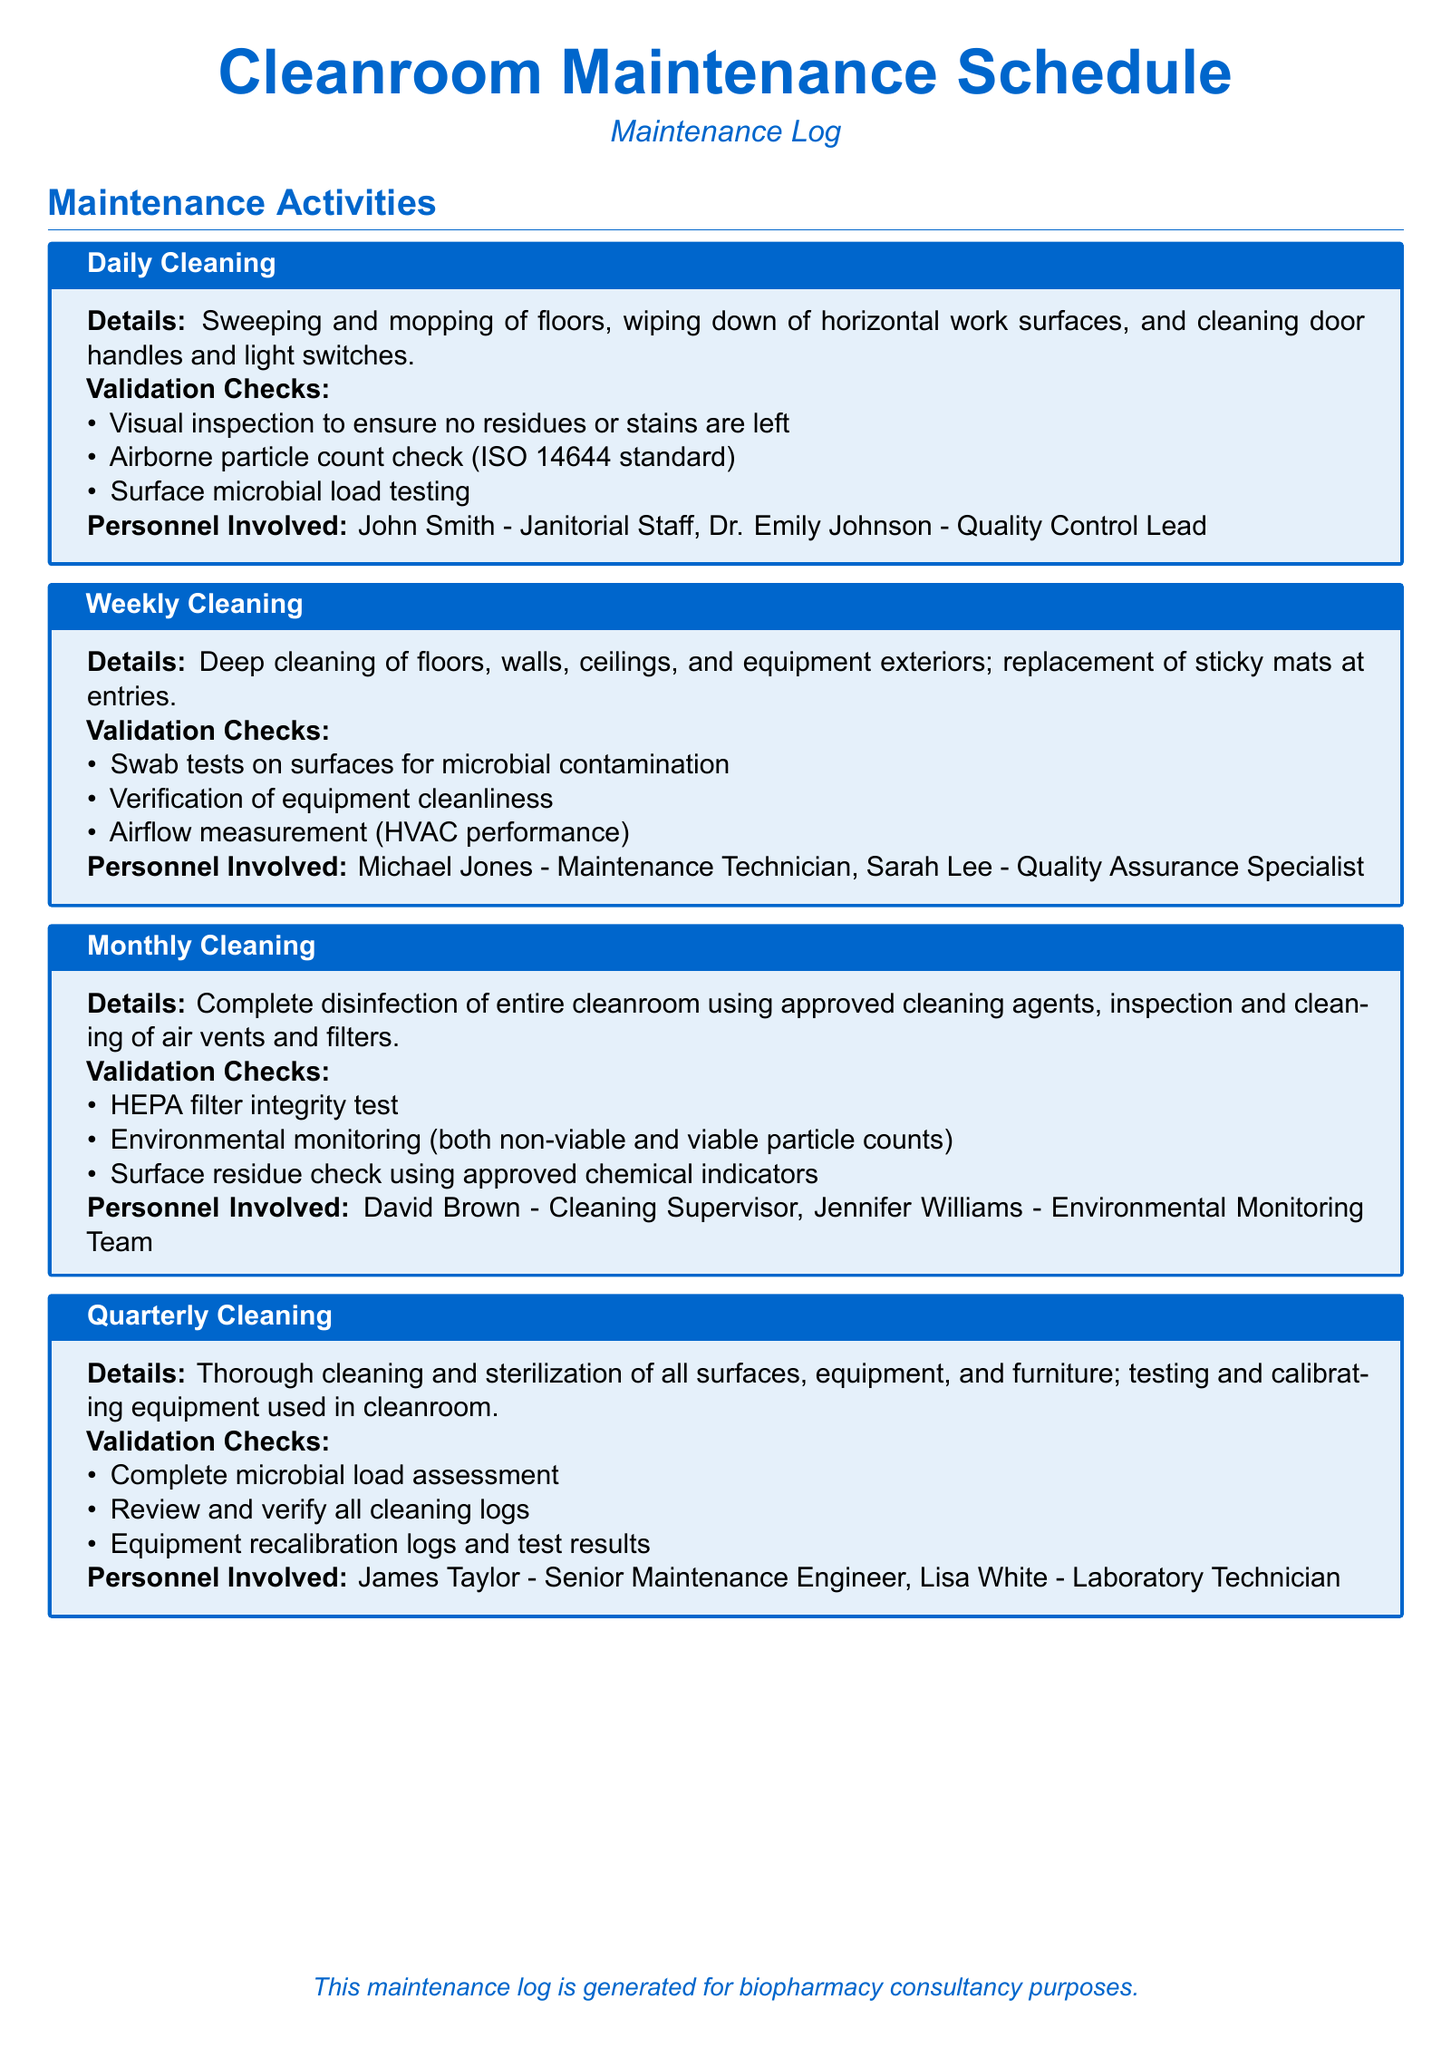What is the title of the document? The title of the document is presented at the top, clearly stating its purpose.
Answer: Cleanroom Maintenance Schedule Who is responsible for daily cleaning activities? The personnel involved in daily cleaning activities are listed in the corresponding section.
Answer: John Smith - Janitorial Staff, Dr. Emily Johnson - Quality Control Lead What type of cleaning is performed monthly? The cleaning activities are described in detail under each section, including the type of cleaning.
Answer: Complete disinfection How often are air vents and filters inspected and cleaned? The document specifies the frequency of cleaning activities in the monthly section.
Answer: Monthly Which validation check is performed during weekly cleaning? The validation checks associated with each cleaning activity are listed under their respective sections.
Answer: Swab tests on surfaces for microbial contamination What is included in the quarterly cleaning activities? The document outlines the specific maintenance activities conducted quarterly.
Answer: Thorough cleaning and sterilization of all surfaces, equipment, and furniture Who conducts the surface microbial load testing during daily cleaning? The cleaning personnel involved in each activity are identified in their respective sections.
Answer: Dr. Emily Johnson - Quality Control Lead What type of testing is done for HEPA filters? The validation checks for the monthly cleaning specifically mention the type of tests performed.
Answer: Integrity test How many maintenance activities are listed in the document? The document provides a breakdown of cleaning activities by frequency.
Answer: Four 